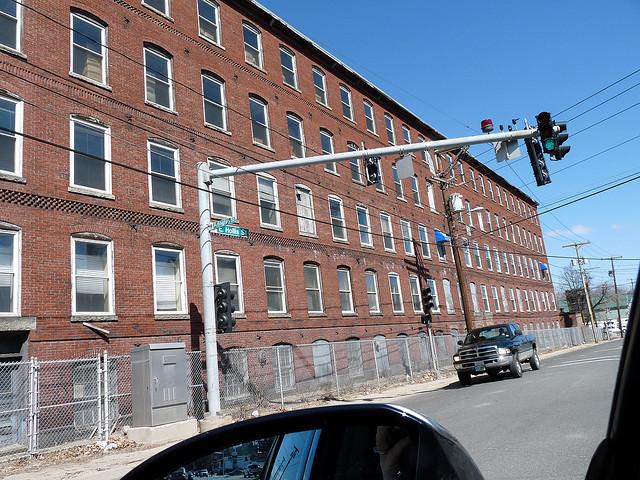Is it daytime?
Quick response, please. Yes. Are there any clouds in this picture?
Give a very brief answer. Yes. What kind of building could this be?
Keep it brief. Apartment. What color is the light post?
Write a very short answer. Gray. How many windows are open?
Short answer required. 0. Is there a school bus in this picture?
Keep it brief. No. 